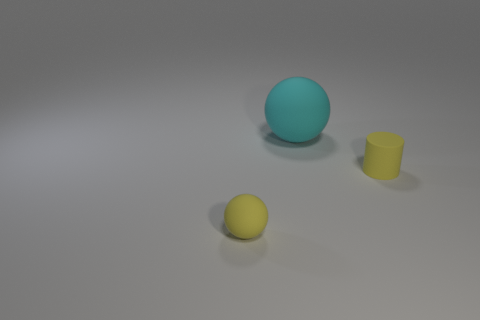What is the color of the cylinder?
Offer a very short reply. Yellow. What material is the object that is in front of the large cyan rubber object and left of the tiny matte cylinder?
Ensure brevity in your answer.  Rubber. There is a rubber sphere that is on the left side of the matte ball behind the yellow rubber sphere; is there a big sphere that is to the left of it?
Keep it short and to the point. No. There is a object that is the same color as the tiny cylinder; what is its size?
Offer a terse response. Small. Are there any small yellow cylinders in front of the rubber cylinder?
Your response must be concise. No. How many other things are there of the same shape as the big cyan object?
Keep it short and to the point. 1. What color is the thing that is the same size as the yellow rubber cylinder?
Your answer should be very brief. Yellow. Is the number of yellow rubber objects that are behind the large ball less than the number of yellow rubber cylinders that are in front of the yellow cylinder?
Give a very brief answer. No. What number of big cyan rubber objects are on the left side of the small object that is to the right of the cyan rubber sphere that is to the left of the small matte cylinder?
Your answer should be very brief. 1. There is another thing that is the same shape as the large matte object; what is its size?
Provide a succinct answer. Small. 